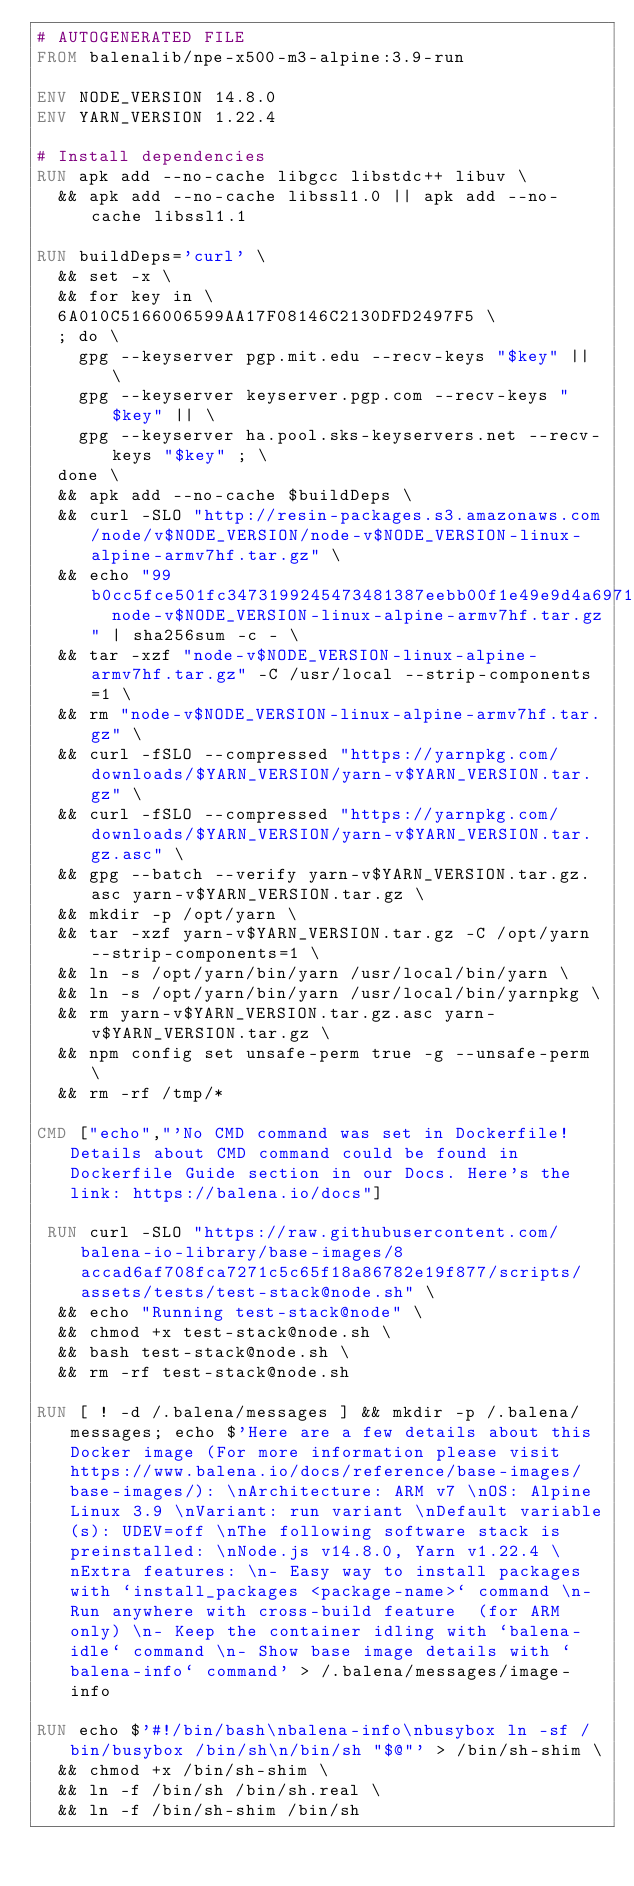<code> <loc_0><loc_0><loc_500><loc_500><_Dockerfile_># AUTOGENERATED FILE
FROM balenalib/npe-x500-m3-alpine:3.9-run

ENV NODE_VERSION 14.8.0
ENV YARN_VERSION 1.22.4

# Install dependencies
RUN apk add --no-cache libgcc libstdc++ libuv \
	&& apk add --no-cache libssl1.0 || apk add --no-cache libssl1.1

RUN buildDeps='curl' \
	&& set -x \
	&& for key in \
	6A010C5166006599AA17F08146C2130DFD2497F5 \
	; do \
		gpg --keyserver pgp.mit.edu --recv-keys "$key" || \
		gpg --keyserver keyserver.pgp.com --recv-keys "$key" || \
		gpg --keyserver ha.pool.sks-keyservers.net --recv-keys "$key" ; \
	done \
	&& apk add --no-cache $buildDeps \
	&& curl -SLO "http://resin-packages.s3.amazonaws.com/node/v$NODE_VERSION/node-v$NODE_VERSION-linux-alpine-armv7hf.tar.gz" \
	&& echo "99b0cc5fce501fc3473199245473481387eebb00f1e49e9d4a6971742de1bdbe  node-v$NODE_VERSION-linux-alpine-armv7hf.tar.gz" | sha256sum -c - \
	&& tar -xzf "node-v$NODE_VERSION-linux-alpine-armv7hf.tar.gz" -C /usr/local --strip-components=1 \
	&& rm "node-v$NODE_VERSION-linux-alpine-armv7hf.tar.gz" \
	&& curl -fSLO --compressed "https://yarnpkg.com/downloads/$YARN_VERSION/yarn-v$YARN_VERSION.tar.gz" \
	&& curl -fSLO --compressed "https://yarnpkg.com/downloads/$YARN_VERSION/yarn-v$YARN_VERSION.tar.gz.asc" \
	&& gpg --batch --verify yarn-v$YARN_VERSION.tar.gz.asc yarn-v$YARN_VERSION.tar.gz \
	&& mkdir -p /opt/yarn \
	&& tar -xzf yarn-v$YARN_VERSION.tar.gz -C /opt/yarn --strip-components=1 \
	&& ln -s /opt/yarn/bin/yarn /usr/local/bin/yarn \
	&& ln -s /opt/yarn/bin/yarn /usr/local/bin/yarnpkg \
	&& rm yarn-v$YARN_VERSION.tar.gz.asc yarn-v$YARN_VERSION.tar.gz \
	&& npm config set unsafe-perm true -g --unsafe-perm \
	&& rm -rf /tmp/*

CMD ["echo","'No CMD command was set in Dockerfile! Details about CMD command could be found in Dockerfile Guide section in our Docs. Here's the link: https://balena.io/docs"]

 RUN curl -SLO "https://raw.githubusercontent.com/balena-io-library/base-images/8accad6af708fca7271c5c65f18a86782e19f877/scripts/assets/tests/test-stack@node.sh" \
  && echo "Running test-stack@node" \
  && chmod +x test-stack@node.sh \
  && bash test-stack@node.sh \
  && rm -rf test-stack@node.sh 

RUN [ ! -d /.balena/messages ] && mkdir -p /.balena/messages; echo $'Here are a few details about this Docker image (For more information please visit https://www.balena.io/docs/reference/base-images/base-images/): \nArchitecture: ARM v7 \nOS: Alpine Linux 3.9 \nVariant: run variant \nDefault variable(s): UDEV=off \nThe following software stack is preinstalled: \nNode.js v14.8.0, Yarn v1.22.4 \nExtra features: \n- Easy way to install packages with `install_packages <package-name>` command \n- Run anywhere with cross-build feature  (for ARM only) \n- Keep the container idling with `balena-idle` command \n- Show base image details with `balena-info` command' > /.balena/messages/image-info

RUN echo $'#!/bin/bash\nbalena-info\nbusybox ln -sf /bin/busybox /bin/sh\n/bin/sh "$@"' > /bin/sh-shim \
	&& chmod +x /bin/sh-shim \
	&& ln -f /bin/sh /bin/sh.real \
	&& ln -f /bin/sh-shim /bin/sh</code> 